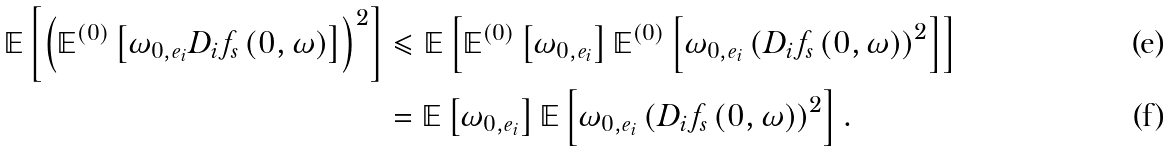Convert formula to latex. <formula><loc_0><loc_0><loc_500><loc_500>\mathbb { E } \left [ \left ( \mathbb { E } ^ { ( 0 ) } \left [ \omega _ { 0 , e _ { i } } D _ { i } f _ { s } \left ( 0 , \omega \right ) \right ] \right ) ^ { 2 } \right ] & \leqslant \mathbb { E } \left [ \mathbb { E } ^ { ( 0 ) } \left [ \omega _ { 0 , e _ { i } } \right ] \mathbb { E } ^ { ( 0 ) } \left [ \omega _ { 0 , e _ { i } } \left ( D _ { i } f _ { s } \left ( 0 , \omega \right ) \right ) ^ { 2 } \right ] \right ] \\ & = \mathbb { E } \left [ \omega _ { 0 , e _ { i } } \right ] \mathbb { E } \left [ \omega _ { 0 , e _ { i } } \left ( D _ { i } f _ { s } \left ( 0 , \omega \right ) \right ) ^ { 2 } \right ] .</formula> 